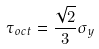<formula> <loc_0><loc_0><loc_500><loc_500>\tau _ { o c t } = \frac { \sqrt { 2 } } { 3 } \sigma _ { y }</formula> 